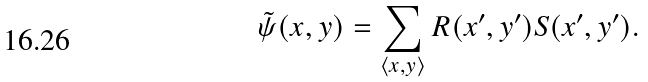<formula> <loc_0><loc_0><loc_500><loc_500>\tilde { \psi } ( x , y ) = \sum _ { \langle x , y \rangle } R ( x ^ { \prime } , y ^ { \prime } ) S ( x ^ { \prime } , y ^ { \prime } ) .</formula> 